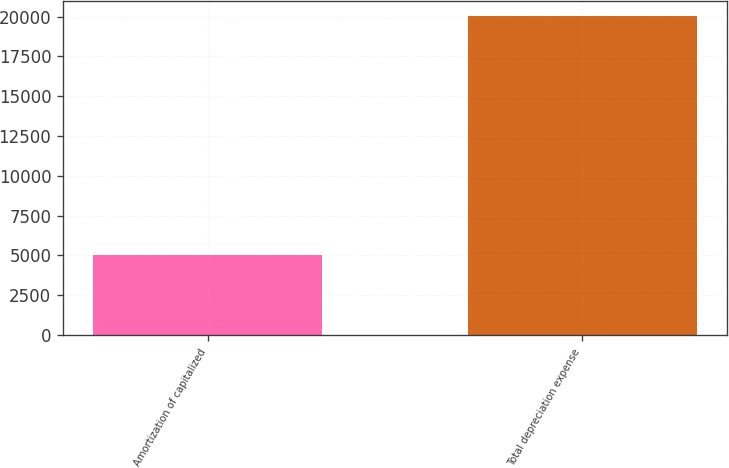<chart> <loc_0><loc_0><loc_500><loc_500><bar_chart><fcel>Amortization of capitalized<fcel>Total depreciation expense<nl><fcel>5058<fcel>20006<nl></chart> 